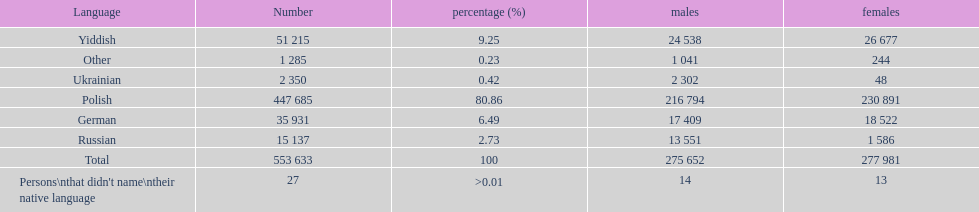How many speakers are represented in polish? 447 685. How many represented speakers are yiddish? 51 215. What is the total number of speakers? 553 633. 